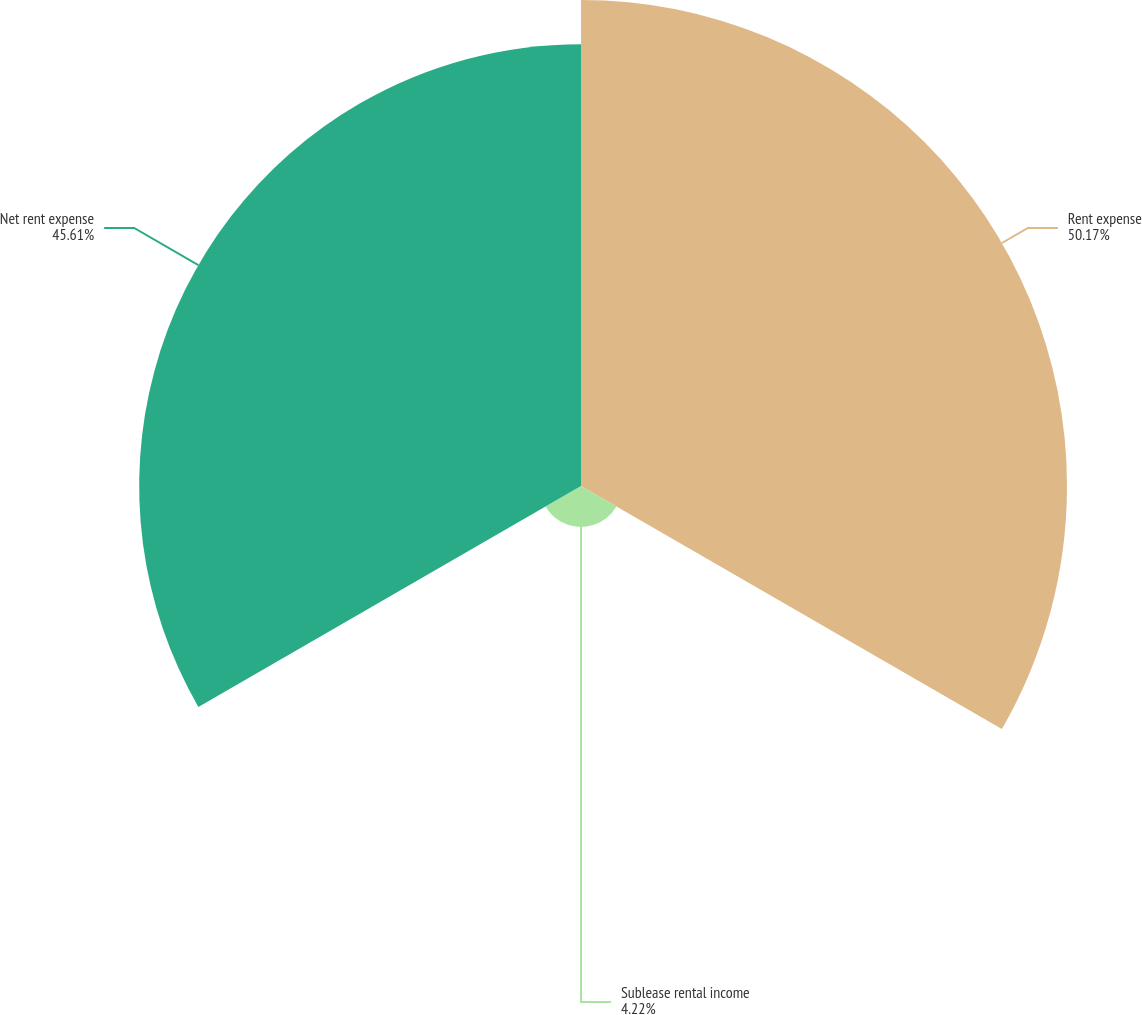Convert chart to OTSL. <chart><loc_0><loc_0><loc_500><loc_500><pie_chart><fcel>Rent expense<fcel>Sublease rental income<fcel>Net rent expense<nl><fcel>50.17%<fcel>4.22%<fcel>45.61%<nl></chart> 